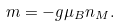<formula> <loc_0><loc_0><loc_500><loc_500>m = - g \mu _ { B } n _ { M } .</formula> 